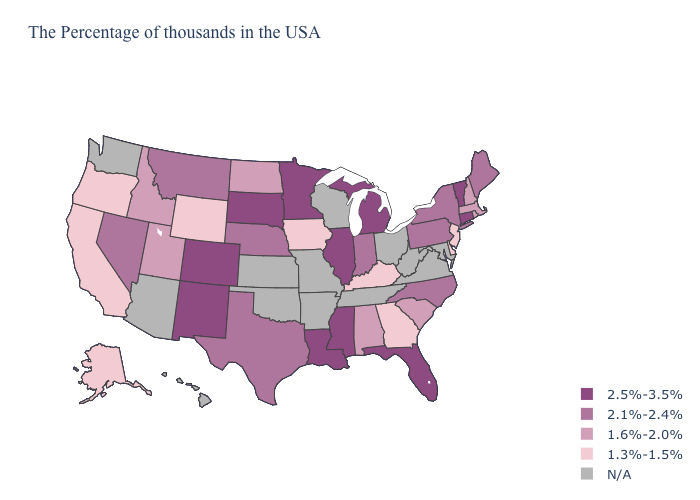Name the states that have a value in the range 2.1%-2.4%?
Give a very brief answer. Maine, New York, Pennsylvania, North Carolina, Indiana, Nebraska, Texas, Montana, Nevada. Does Iowa have the lowest value in the MidWest?
Short answer required. Yes. Among the states that border Kansas , does Nebraska have the highest value?
Short answer required. No. What is the lowest value in the South?
Give a very brief answer. 1.3%-1.5%. Which states have the highest value in the USA?
Short answer required. Vermont, Connecticut, Florida, Michigan, Illinois, Mississippi, Louisiana, Minnesota, South Dakota, Colorado, New Mexico. What is the highest value in the USA?
Concise answer only. 2.5%-3.5%. What is the value of Georgia?
Keep it brief. 1.3%-1.5%. What is the lowest value in the South?
Quick response, please. 1.3%-1.5%. Name the states that have a value in the range 1.6%-2.0%?
Answer briefly. Massachusetts, Rhode Island, New Hampshire, South Carolina, Alabama, North Dakota, Utah, Idaho. Does Vermont have the highest value in the USA?
Give a very brief answer. Yes. Does New Jersey have the lowest value in the Northeast?
Be succinct. Yes. What is the highest value in states that border Delaware?
Keep it brief. 2.1%-2.4%. Name the states that have a value in the range 2.5%-3.5%?
Quick response, please. Vermont, Connecticut, Florida, Michigan, Illinois, Mississippi, Louisiana, Minnesota, South Dakota, Colorado, New Mexico. 